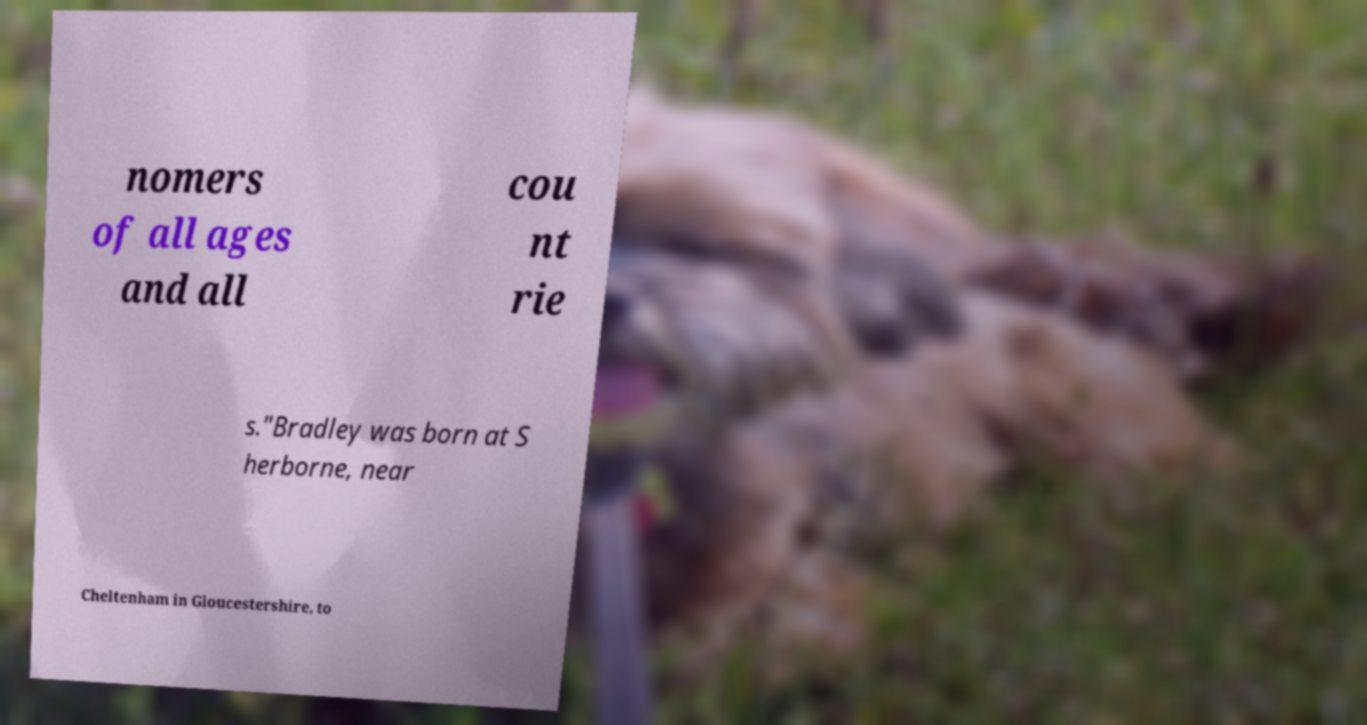There's text embedded in this image that I need extracted. Can you transcribe it verbatim? nomers of all ages and all cou nt rie s."Bradley was born at S herborne, near Cheltenham in Gloucestershire, to 